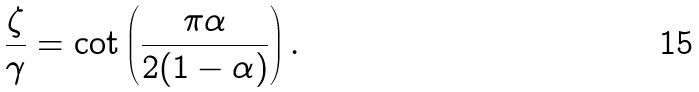<formula> <loc_0><loc_0><loc_500><loc_500>\frac { \zeta } { \gamma } = \cot \left ( \frac { \pi \alpha } { 2 ( 1 - \alpha ) } \right ) .</formula> 